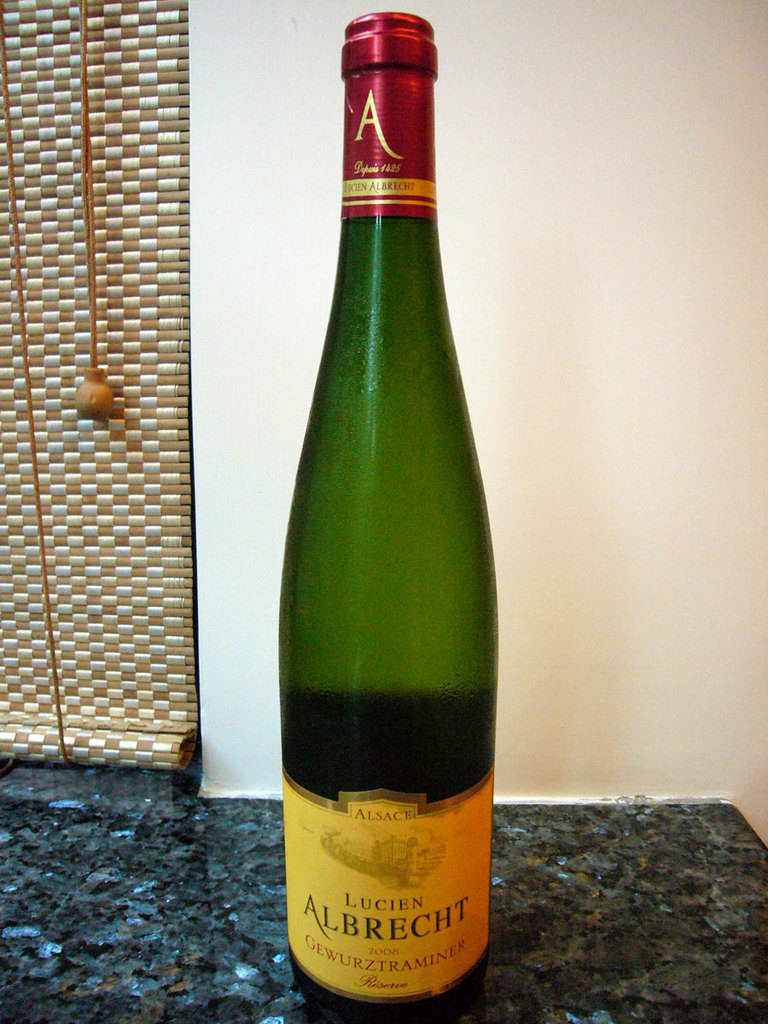What can you tell me about the type of wine featured in the image? The wine in the image is a Gewurztraminer, which is known for its aromatic profile, often rich with notes of lychee, rose, ginger, and a hint of sweetness. It hails from Alsace, a region noted for its exceptional white wines. 